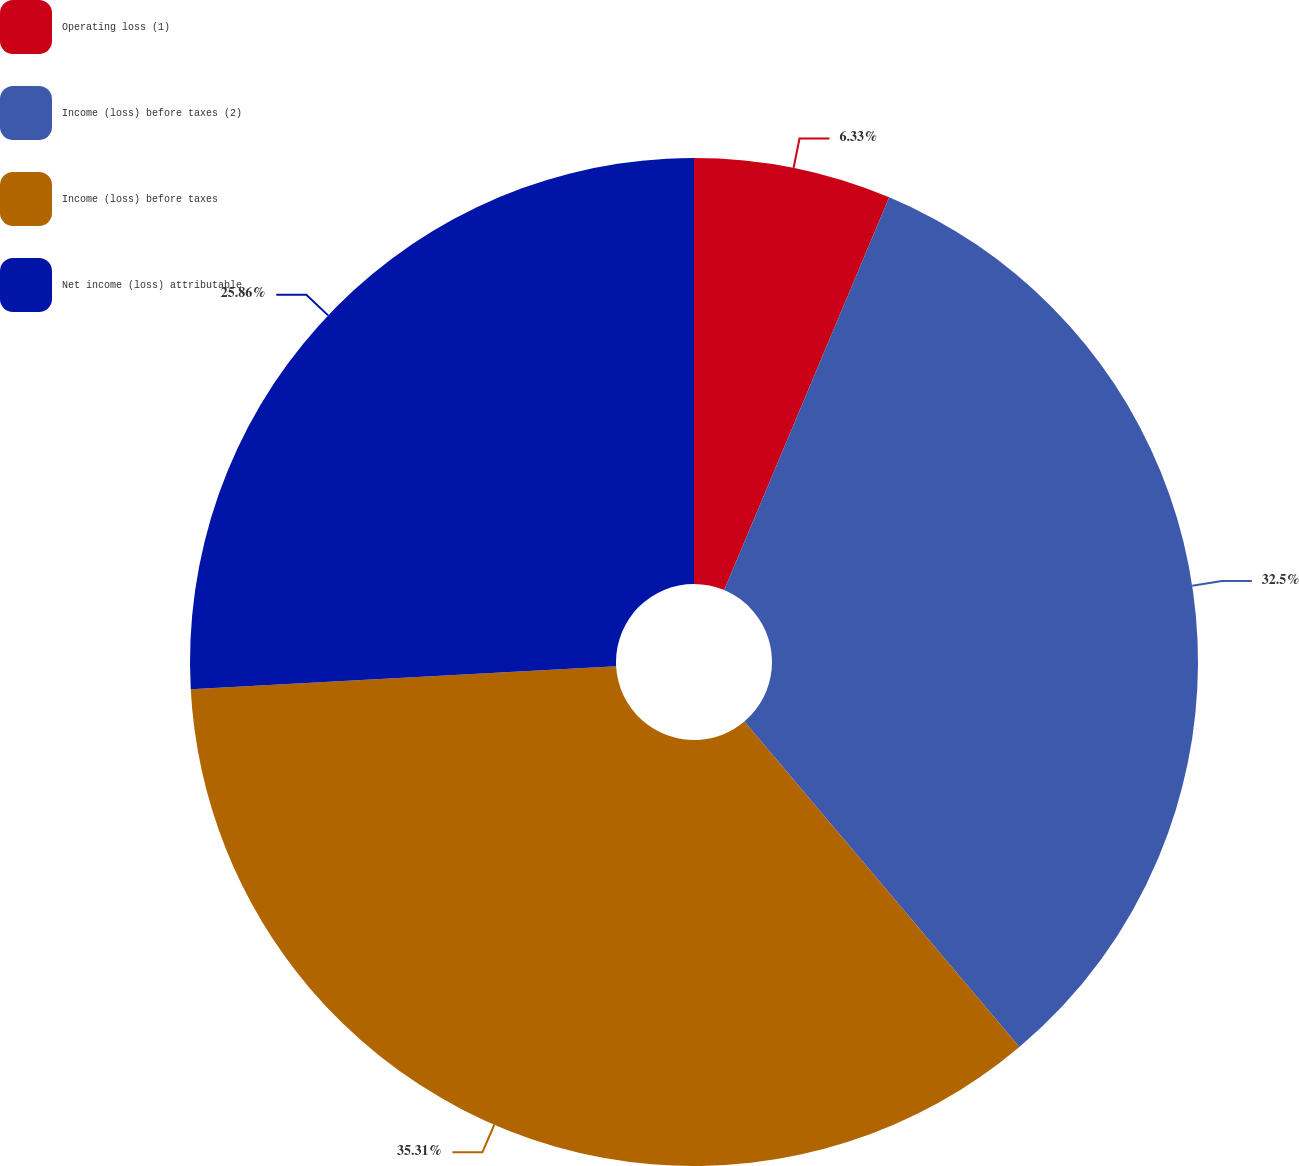Convert chart. <chart><loc_0><loc_0><loc_500><loc_500><pie_chart><fcel>Operating loss (1)<fcel>Income (loss) before taxes (2)<fcel>Income (loss) before taxes<fcel>Net income (loss) attributable<nl><fcel>6.33%<fcel>32.5%<fcel>35.31%<fcel>25.86%<nl></chart> 